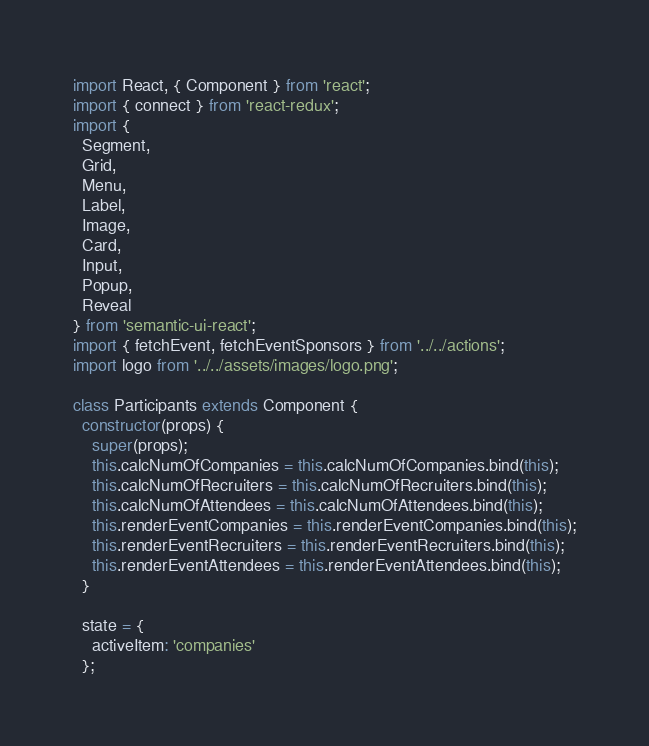Convert code to text. <code><loc_0><loc_0><loc_500><loc_500><_JavaScript_>import React, { Component } from 'react';
import { connect } from 'react-redux';
import {
  Segment,
  Grid,
  Menu,
  Label,
  Image,
  Card,
  Input,
  Popup,
  Reveal
} from 'semantic-ui-react';
import { fetchEvent, fetchEventSponsors } from '../../actions';
import logo from '../../assets/images/logo.png';

class Participants extends Component {
  constructor(props) {
    super(props);
    this.calcNumOfCompanies = this.calcNumOfCompanies.bind(this);
    this.calcNumOfRecruiters = this.calcNumOfRecruiters.bind(this);
    this.calcNumOfAttendees = this.calcNumOfAttendees.bind(this);
    this.renderEventCompanies = this.renderEventCompanies.bind(this);
    this.renderEventRecruiters = this.renderEventRecruiters.bind(this);
    this.renderEventAttendees = this.renderEventAttendees.bind(this);
  }

  state = {
    activeItem: 'companies'
  };
</code> 